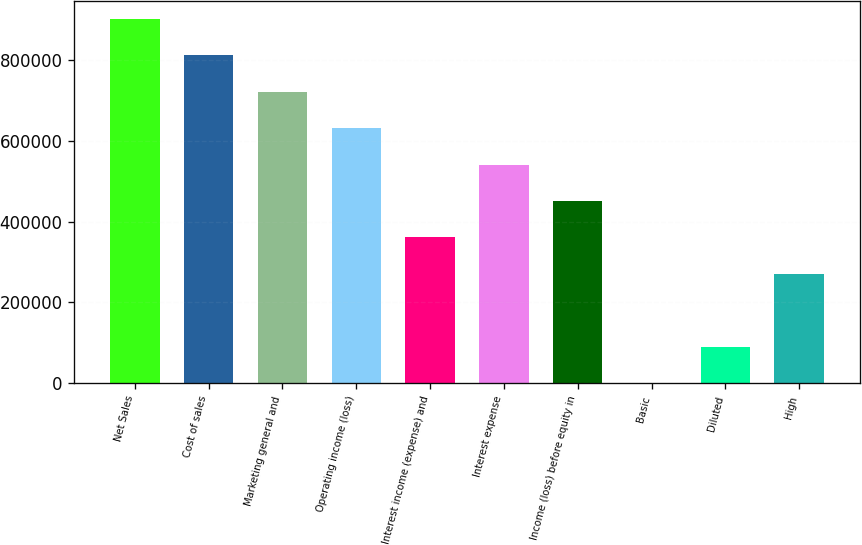Convert chart to OTSL. <chart><loc_0><loc_0><loc_500><loc_500><bar_chart><fcel>Net Sales<fcel>Cost of sales<fcel>Marketing general and<fcel>Operating income (loss)<fcel>Interest income (expense) and<fcel>Interest expense<fcel>Income (loss) before equity in<fcel>Basic<fcel>Diluted<fcel>High<nl><fcel>902073<fcel>811866<fcel>721658<fcel>631451<fcel>360829<fcel>541244<fcel>451037<fcel>0.03<fcel>90207.3<fcel>270622<nl></chart> 